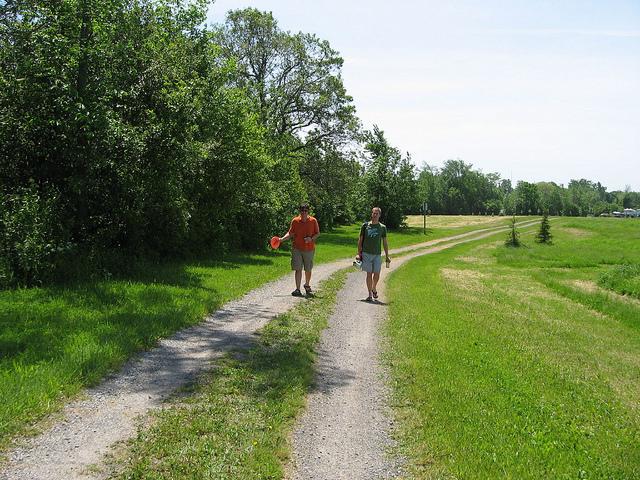Does this seem peaceful?
Be succinct. Yes. What is the man on the left holding?
Write a very short answer. Frisbee. Are they going for a walk?
Quick response, please. Yes. 